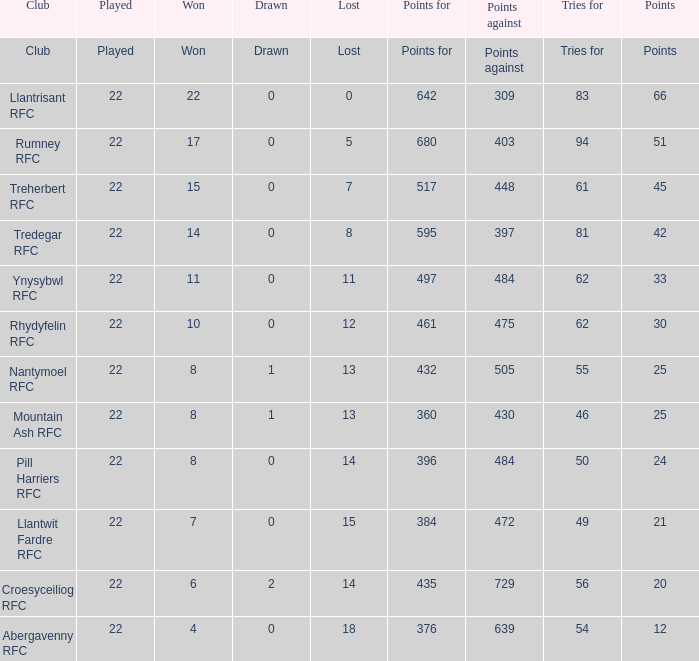Which club lost exactly 7 matches? Treherbert RFC. 